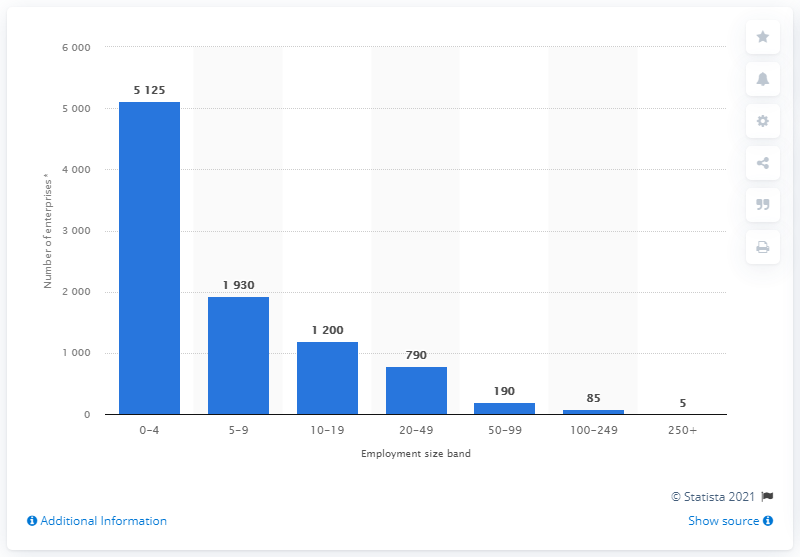Give some essential details in this illustration. The difference between the highest and lowest blue bar is 5120. In the United Kingdom (UK) in 2020, the maximum number of specialized stores for the retail sale of hardware, paints, and glass was Permitted for businesses with 5125 or more employees. 